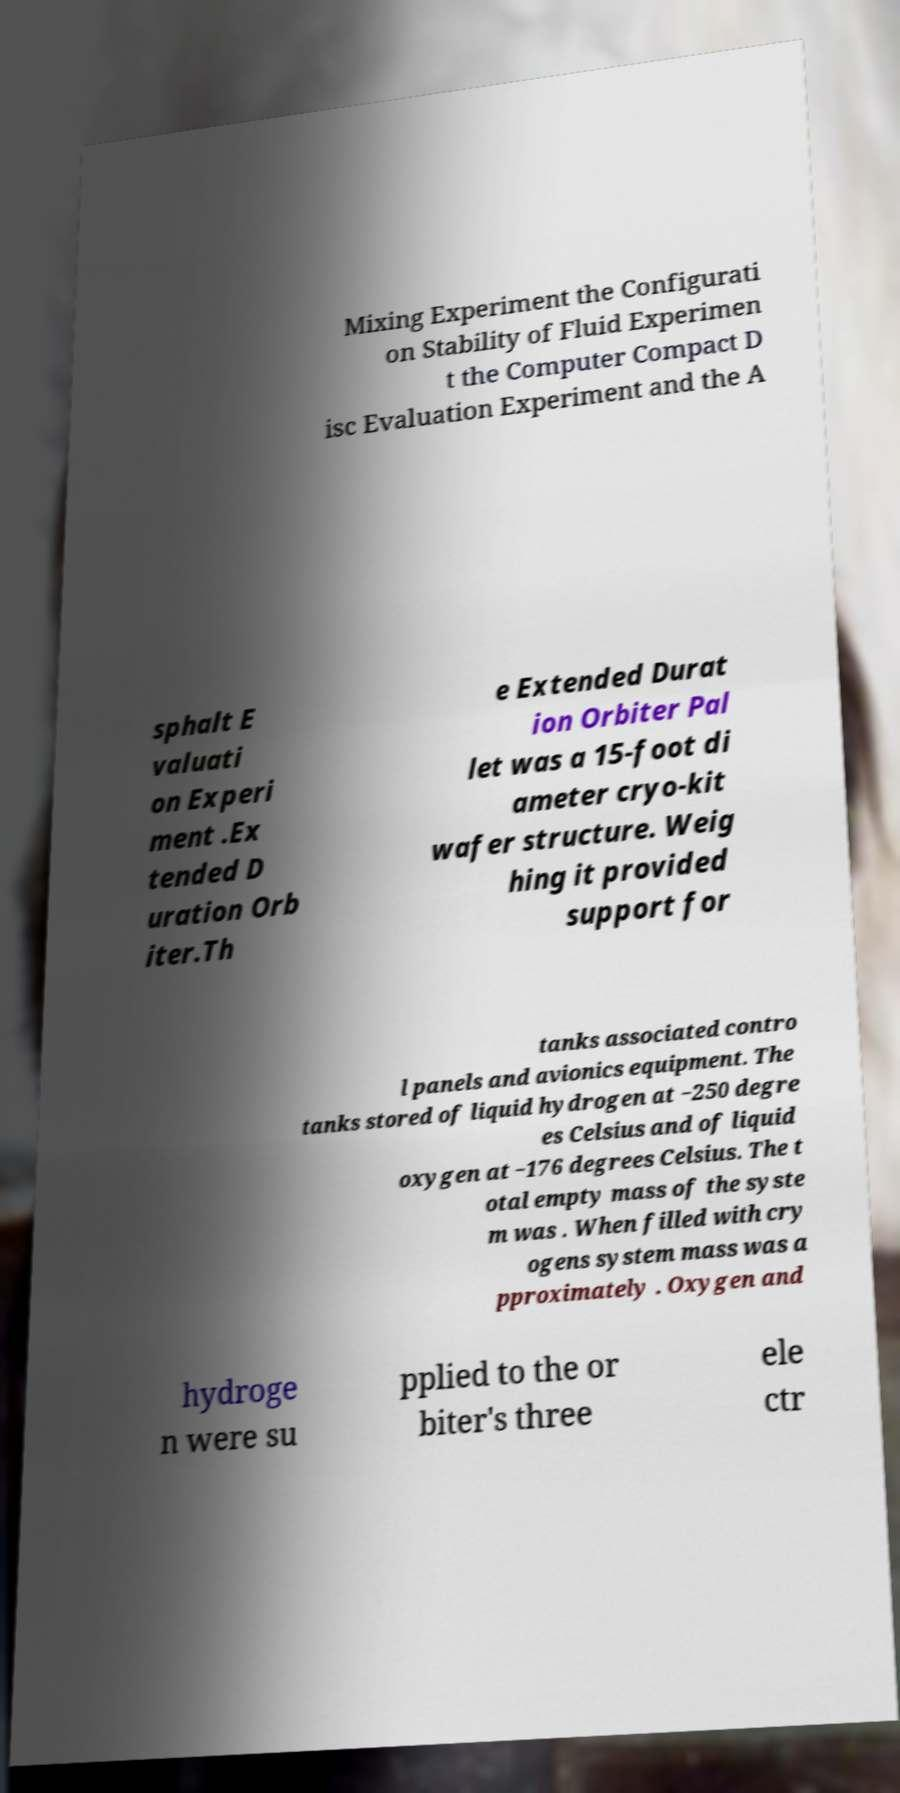Could you extract and type out the text from this image? Mixing Experiment the Configurati on Stability of Fluid Experimen t the Computer Compact D isc Evaluation Experiment and the A sphalt E valuati on Experi ment .Ex tended D uration Orb iter.Th e Extended Durat ion Orbiter Pal let was a 15-foot di ameter cryo-kit wafer structure. Weig hing it provided support for tanks associated contro l panels and avionics equipment. The tanks stored of liquid hydrogen at −250 degre es Celsius and of liquid oxygen at −176 degrees Celsius. The t otal empty mass of the syste m was . When filled with cry ogens system mass was a pproximately . Oxygen and hydroge n were su pplied to the or biter's three ele ctr 